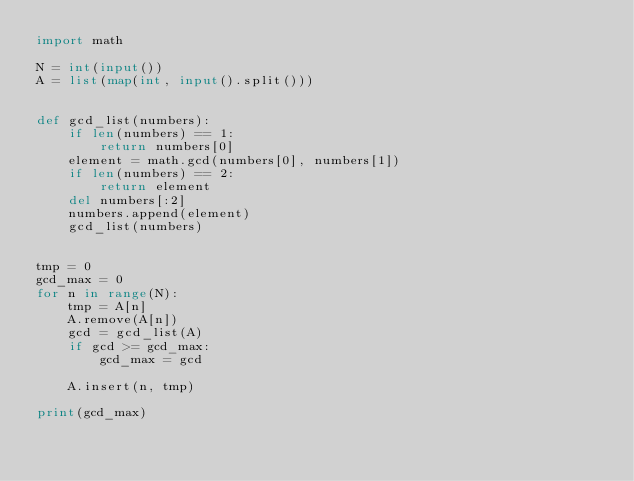<code> <loc_0><loc_0><loc_500><loc_500><_Python_>import math

N = int(input())
A = list(map(int, input().split()))


def gcd_list(numbers):
    if len(numbers) == 1:
        return numbers[0]
    element = math.gcd(numbers[0], numbers[1])
    if len(numbers) == 2:
        return element
    del numbers[:2]
    numbers.append(element)
    gcd_list(numbers)


tmp = 0
gcd_max = 0
for n in range(N):
    tmp = A[n]
    A.remove(A[n])
    gcd = gcd_list(A)
    if gcd >= gcd_max:
        gcd_max = gcd

    A.insert(n, tmp)

print(gcd_max)
</code> 